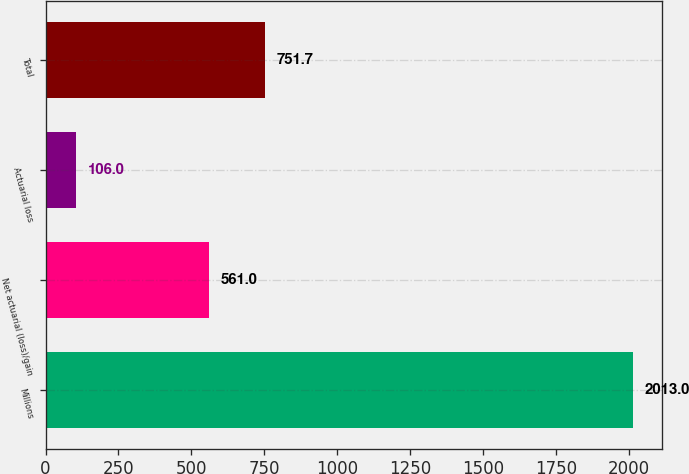<chart> <loc_0><loc_0><loc_500><loc_500><bar_chart><fcel>Millions<fcel>Net actuarial (loss)/gain<fcel>Actuarial loss<fcel>Total<nl><fcel>2013<fcel>561<fcel>106<fcel>751.7<nl></chart> 